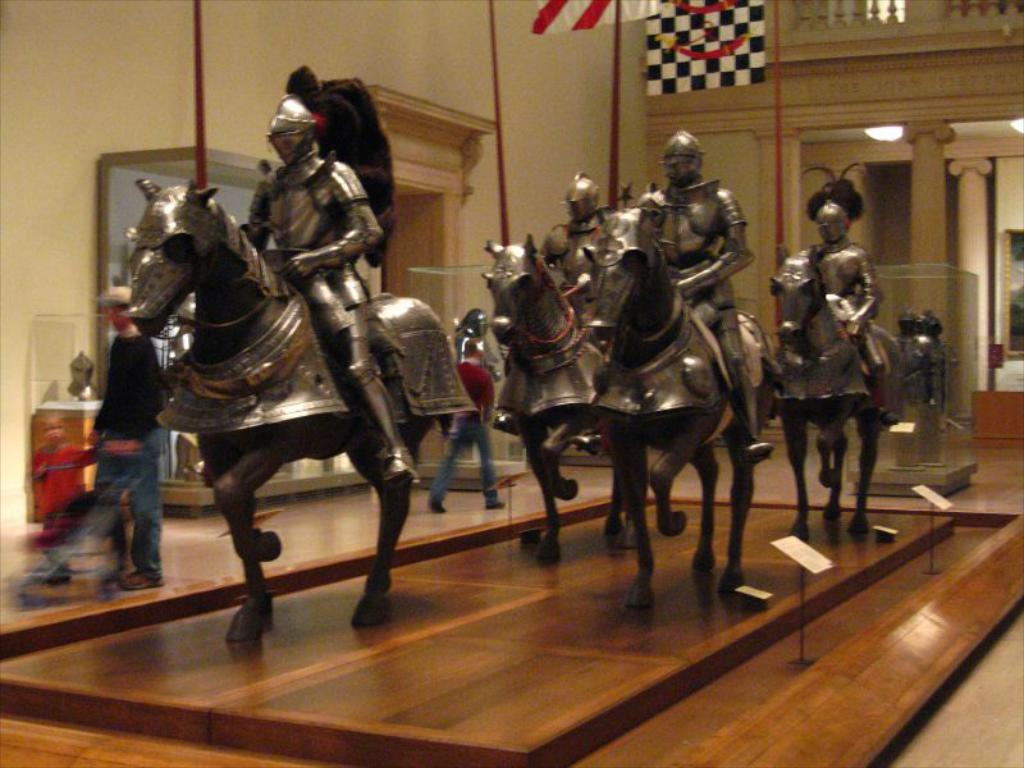What is the main subject of the image? The main subject of the image is a statue. What is the statue depicting? The statue depicts a person riding a horse. Are there any people visible in the image besides the statue? Yes, there are people walking behind the statue. What other structures or objects can be seen in the image? There is a wall and a flag in the image. What type of string is being used to hold up the sofa in the image? There is no sofa present in the image, so there is no string being used to hold it up. 